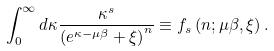<formula> <loc_0><loc_0><loc_500><loc_500>\int _ { 0 } ^ { \infty } d \kappa \frac { \kappa ^ { s } } { \left ( e ^ { \kappa - \mu \beta } + \xi \right ) ^ { n } } \equiv f _ { s } \left ( n ; \mu \beta , \xi \right ) .</formula> 